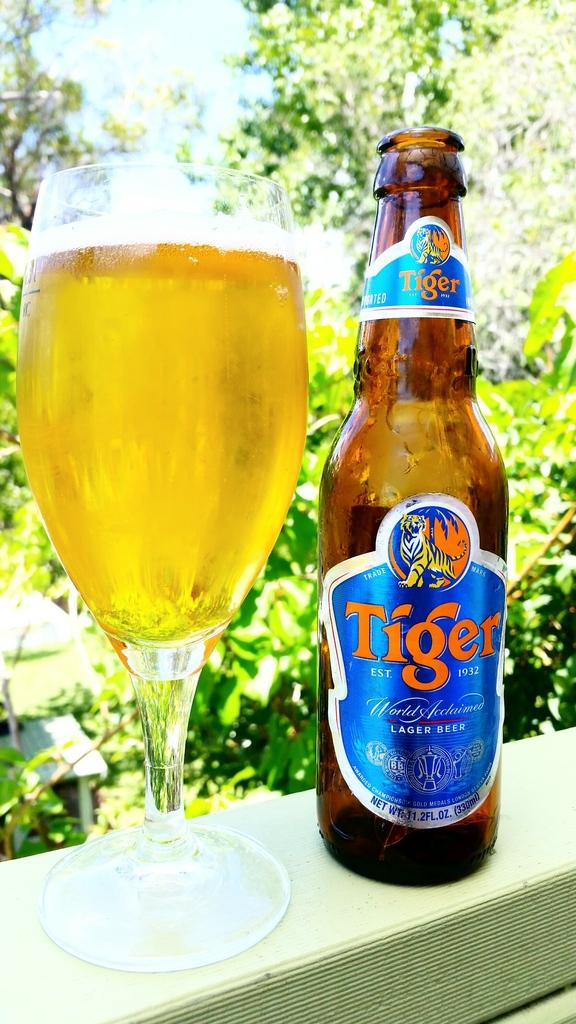Provide a one-sentence caption for the provided image. A glass of Tiger Lager with an empty bottle sits on a ledge. 